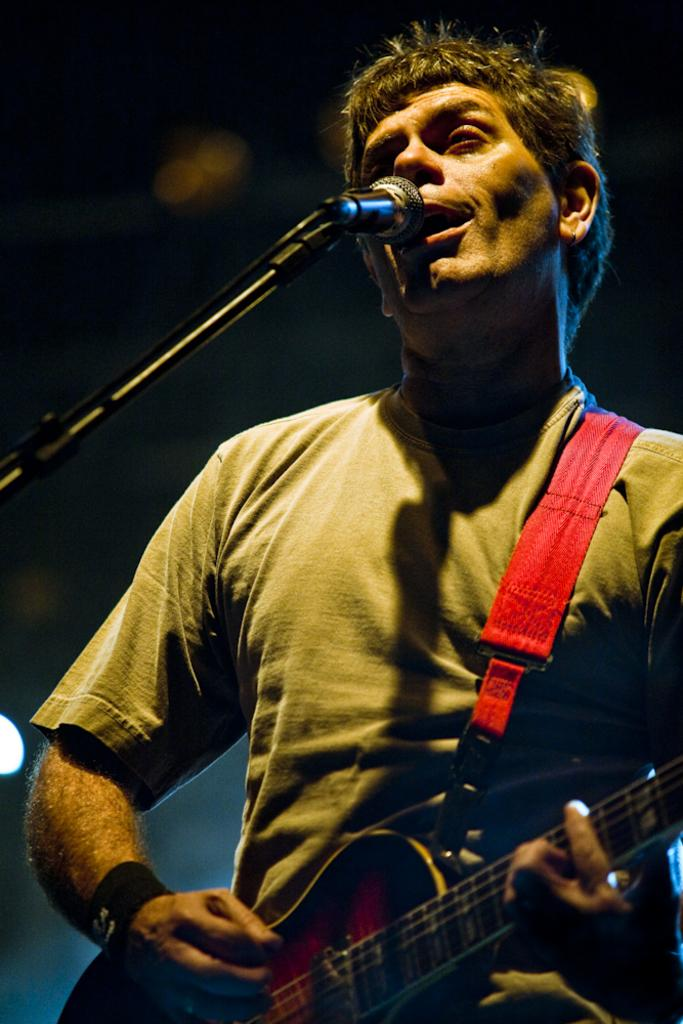What type of event is depicted in the image? The image is from a musical concert. What is the man in the image doing? The man is singing in the image. What is the man using to amplify his voice? There is a microphone in front of the man. What musical instrument is the man playing? The man is playing a guitar. What color is the shirt the man is wearing? The man is wearing a grey shirt. What type of liquid is being poured on the guitar in the image? There is no liquid being poured on the guitar in the image. What type of jeans is the man wearing in the image? The provided facts do not mention the man's pants, so we cannot determine if he is wearing jeans or any other type of clothing. 